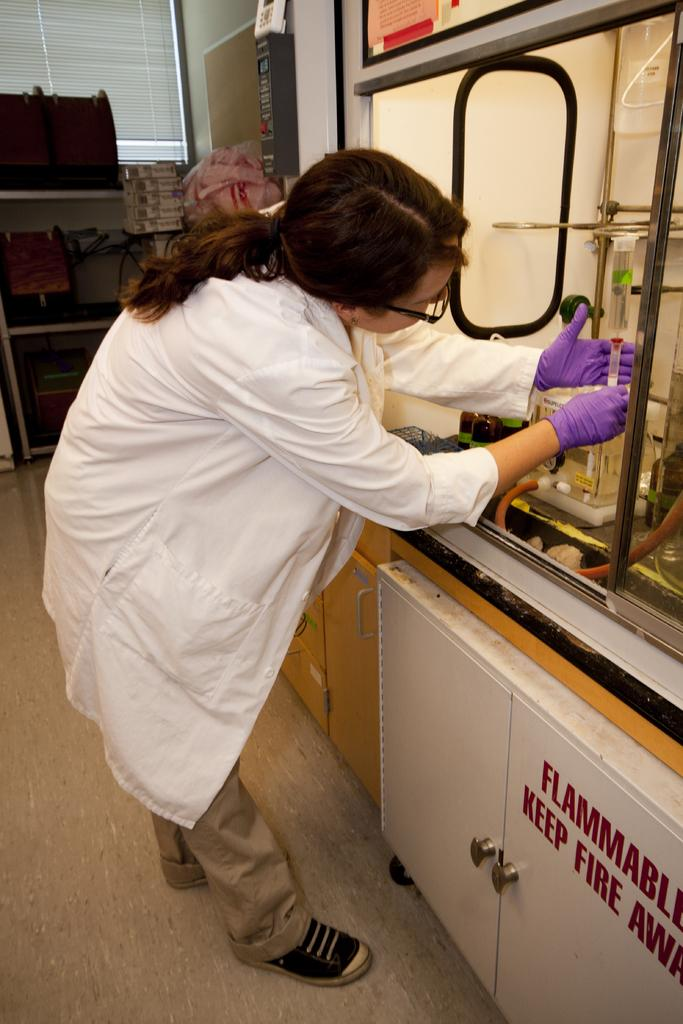<image>
Offer a succinct explanation of the picture presented. A woman works in a fume hood that has the word "flammable" on the cabinet underneath. 